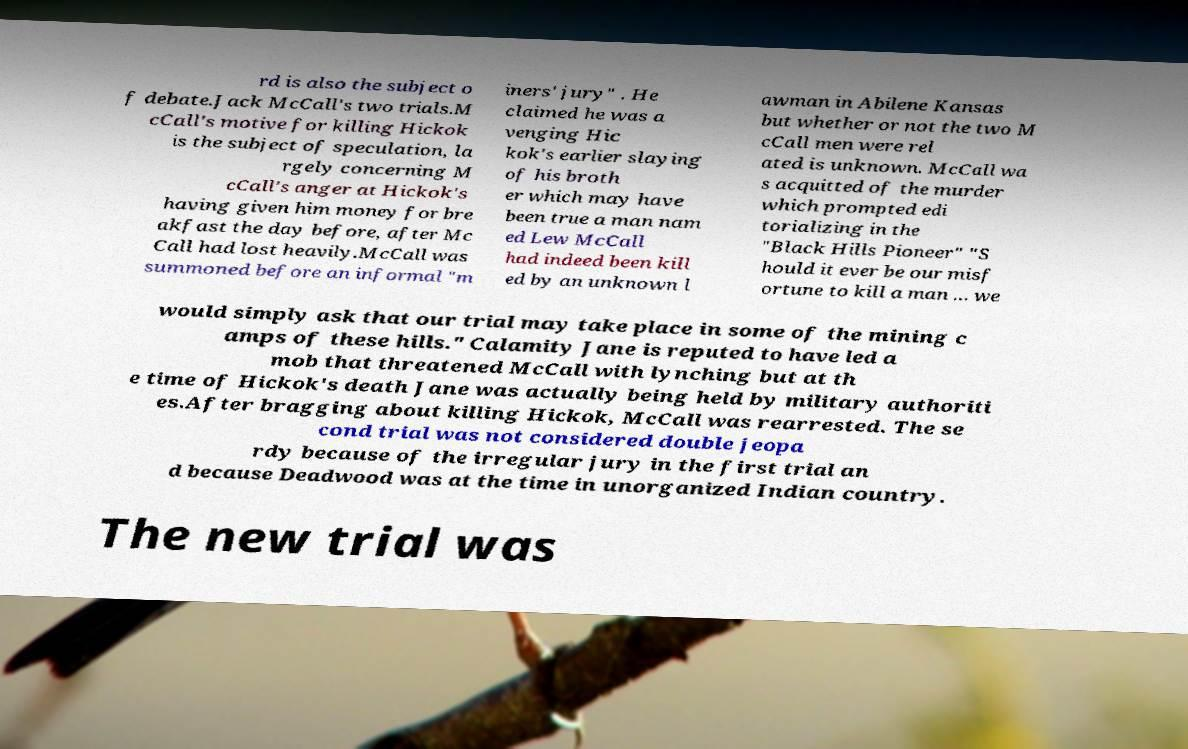Can you read and provide the text displayed in the image?This photo seems to have some interesting text. Can you extract and type it out for me? rd is also the subject o f debate.Jack McCall's two trials.M cCall's motive for killing Hickok is the subject of speculation, la rgely concerning M cCall's anger at Hickok's having given him money for bre akfast the day before, after Mc Call had lost heavily.McCall was summoned before an informal "m iners' jury" . He claimed he was a venging Hic kok's earlier slaying of his broth er which may have been true a man nam ed Lew McCall had indeed been kill ed by an unknown l awman in Abilene Kansas but whether or not the two M cCall men were rel ated is unknown. McCall wa s acquitted of the murder which prompted edi torializing in the "Black Hills Pioneer" "S hould it ever be our misf ortune to kill a man ... we would simply ask that our trial may take place in some of the mining c amps of these hills." Calamity Jane is reputed to have led a mob that threatened McCall with lynching but at th e time of Hickok's death Jane was actually being held by military authoriti es.After bragging about killing Hickok, McCall was rearrested. The se cond trial was not considered double jeopa rdy because of the irregular jury in the first trial an d because Deadwood was at the time in unorganized Indian country. The new trial was 